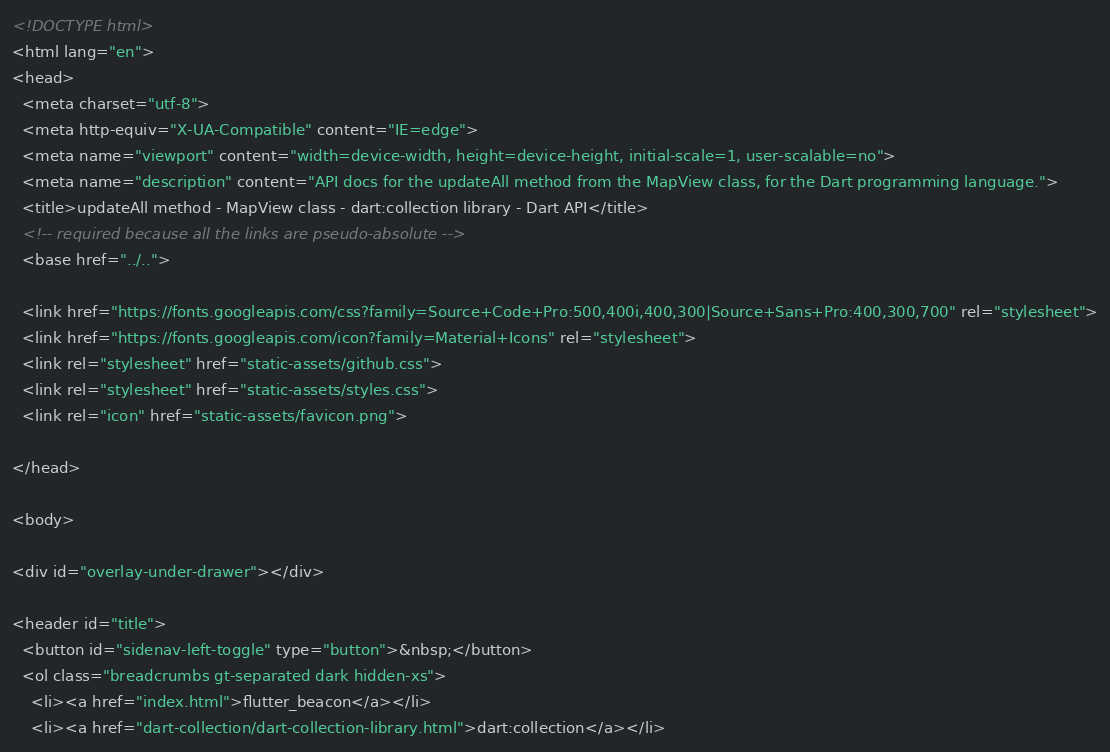Convert code to text. <code><loc_0><loc_0><loc_500><loc_500><_HTML_><!DOCTYPE html>
<html lang="en">
<head>
  <meta charset="utf-8">
  <meta http-equiv="X-UA-Compatible" content="IE=edge">
  <meta name="viewport" content="width=device-width, height=device-height, initial-scale=1, user-scalable=no">
  <meta name="description" content="API docs for the updateAll method from the MapView class, for the Dart programming language.">
  <title>updateAll method - MapView class - dart:collection library - Dart API</title>
  <!-- required because all the links are pseudo-absolute -->
  <base href="../..">

  <link href="https://fonts.googleapis.com/css?family=Source+Code+Pro:500,400i,400,300|Source+Sans+Pro:400,300,700" rel="stylesheet">
  <link href="https://fonts.googleapis.com/icon?family=Material+Icons" rel="stylesheet">
  <link rel="stylesheet" href="static-assets/github.css">
  <link rel="stylesheet" href="static-assets/styles.css">
  <link rel="icon" href="static-assets/favicon.png">
  
</head>

<body>

<div id="overlay-under-drawer"></div>

<header id="title">
  <button id="sidenav-left-toggle" type="button">&nbsp;</button>
  <ol class="breadcrumbs gt-separated dark hidden-xs">
    <li><a href="index.html">flutter_beacon</a></li>
    <li><a href="dart-collection/dart-collection-library.html">dart:collection</a></li></code> 